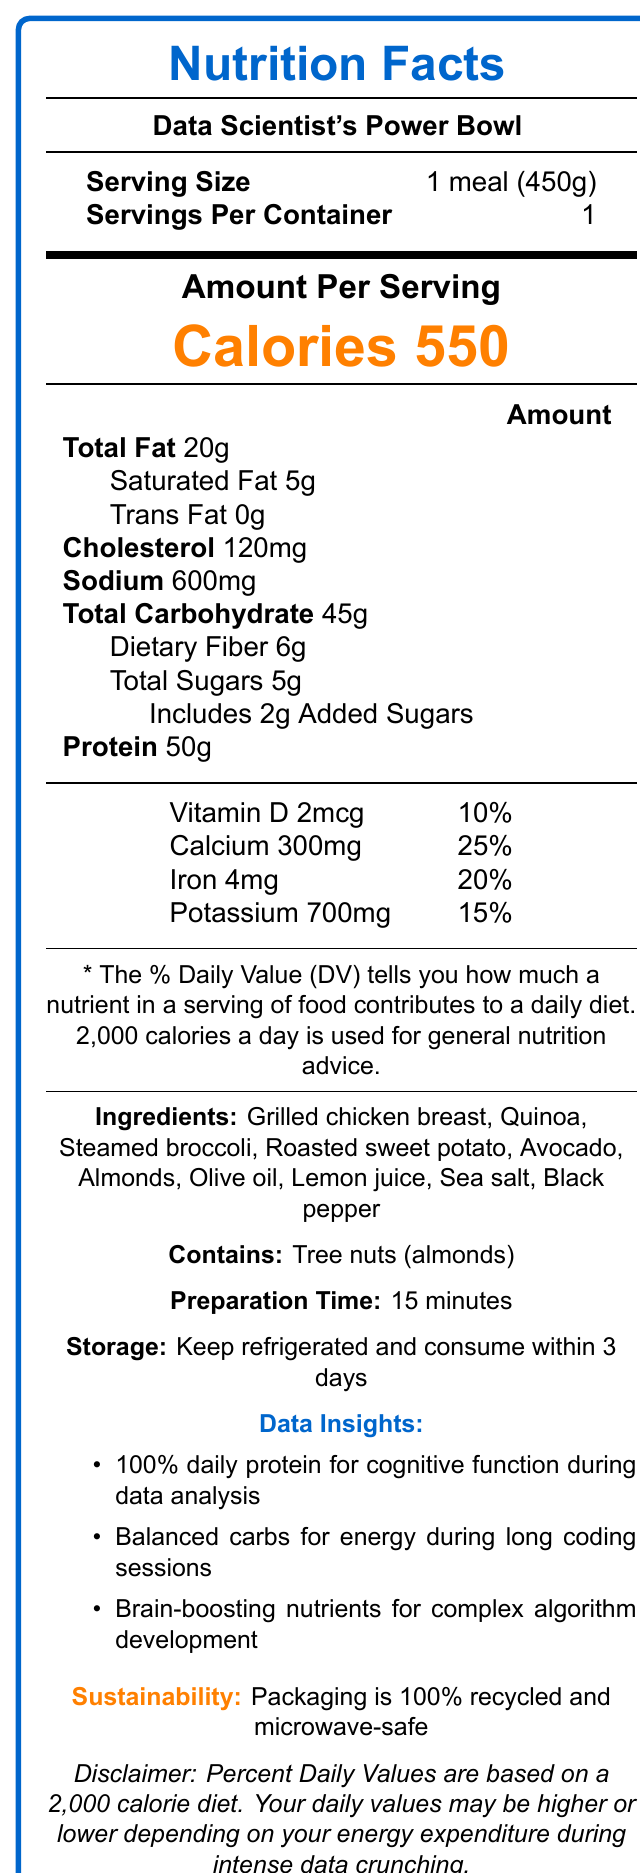what is the serving size? The serving size is listed as "1 meal (450g)" under the Serving Size section.
Answer: 1 meal (450g) how many servings per container? It is mentioned under the Serving Size section that there is 1 serving per container.
Answer: 1 how many calories does one serving contain? The document indicates "Calories 550" clearly under the Amount Per Serving section.
Answer: 550 what is the total fat content and its daily value percentage? The Total Fat content is listed as 20g, and the daily value percentage is 26%.
Answer: 20g, 26% how much protein is in one serving? The Protein content is noted as 50g with a daily value of 100%.
Answer: 50g what ingredients are included in this meal? The Ingredients section lists all the included items.
Answer: Grilled chicken breast, Quinoa, Steamed broccoli, Roasted sweet potato, Avocado, Almonds, Olive oil, Lemon juice, Sea salt, Black pepper how long does it take to prepare this meal? The Preparation Time is noted as "15 minutes."
Answer: 15 minutes how much added sugar is in the meal? The Total Sugars section includes 2g of added sugars, specified under Includes 2g Added Sugars.
Answer: 2g which ingredient listed is a known allergen? A. Grilled chicken breast B. Quinoa C. Almonds D. Broccoli The Allergens section notes "Tree nuts (almonds)."
Answer: C. Almonds what are the storage instructions for this meal? The Storage section directs to "Keep refrigerated and consume within 3 days."
Answer: Keep refrigerated and consume within 3 days how much vitamin D does the meal provide? The document lists the Vitamin D content as 2mcg, with a daily value of 10%.
Answer: 2mcg what nutrient helps maintain steady energy levels according to the data insights? The Data Insights section states that balanced carbohydrate content helps maintain steady energy levels.
Answer: Balanced carbohydrates is the meal packaging microwave-safe? The Sustainability Info mentions that the "container is microwave-safe for easy reheating."
Answer: Yes what nutrient from avocado supports brain health? A. Protein B. Vitamin D C. Omega-3 fatty acids D. Potassium The Data Insights section mentions "Rich in omega-3 fatty acids from avocado."
Answer: C. Omega-3 fatty acids does the meal provide enough protein to meet daily needs? According to the Protein section, the meal provides 50g of protein, which is 100% of the daily value.
Answer: Yes what materials are used for the packaging of the meal? The Sustainability Info section states that the packaging is made from 100% recycled materials.
Answer: 100% recycled materials summarize the main idea of this document. The document lists detailed nutritional values, ingredients, allergens, preparation instructions, and emphasizes health benefits and sustainability features.
Answer: The document provides detailed nutrition facts for the 'Data Scientist's Power Bowl,' a high-protein meal designed for busy data scientists. It includes nutritional information per serving, ingredients, allergens, preparation time, storage instructions, data insights, and sustainability info. what is the daily value percentage for iron in the meal? The Iron content is listed as 4mg, with a daily value of 20%.
Answer: 20% how much cholesterol does one serving contain and its daily value percentage? The Cholesterol amount is 120mg, and the daily value percentage is 40%.
Answer: 120mg, 40% what is the main ingredient used for protein in this meal? The primary protein source, according to the ingredients list, seems to be grilled chicken breast.
Answer: Grilled chicken breast how much calcium does the meal provide? The Calcium content is listed as 300mg, and the daily value is 25%.
Answer: 300mg what are the brain-boosting nutrients mentioned in the data insights section? The Data Insights section highlights these nutrients as supportive for brain health.
Answer: Omega-3 fatty acids from avocado and iron from chicken who is the target audience for this meal plan? The meal name and data insights reveal that the target audience is busy data scientists.
Answer: Busy data scientists how many total sugars are in the meal? The document notes the total sugars as 5g.
Answer: 5g which preparation technique is used for the sweet potato in this meal? A. Steamed B. Roasted C. Boiled The Ingredient list mentions "Roasted sweet potato."
Answer: B. Roasted what type of analysis sessions does the protein content help with, according to the data insights? The Data Insights section indicates that the high protein content is perfect for maintaining cognitive function during intense data analysis sessions.
Answer: Intense data analysis sessions calculate the percentage of daily value for total fat based on the information provided. The document lists Total Fat as 20g with a daily value of 26%.
Answer: 26% what is the theme of the meal's data insights sections? A. High Protein B. Balanced Carbs C. Brain Health D. Sustainability The data insights emphasize 100% daily protein needs, energy balance, and brain health, but especially focus on high protein.
Answer: A. High Protein does the document mention anything about gluten-free status? The document does not provide any information about whether the meal is gluten-free.
Answer: Not enough information 